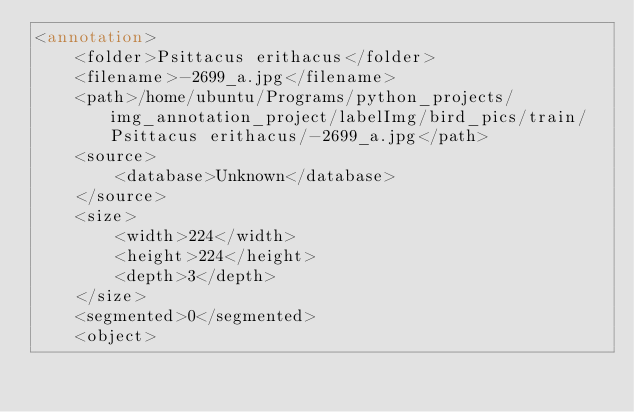<code> <loc_0><loc_0><loc_500><loc_500><_XML_><annotation>
	<folder>Psittacus erithacus</folder>
	<filename>-2699_a.jpg</filename>
	<path>/home/ubuntu/Programs/python_projects/img_annotation_project/labelImg/bird_pics/train/Psittacus erithacus/-2699_a.jpg</path>
	<source>
		<database>Unknown</database>
	</source>
	<size>
		<width>224</width>
		<height>224</height>
		<depth>3</depth>
	</size>
	<segmented>0</segmented>
	<object></code> 